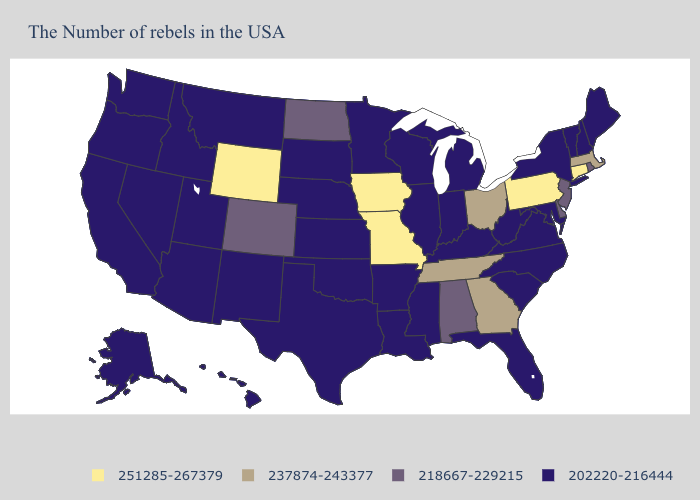What is the highest value in the Northeast ?
Keep it brief. 251285-267379. What is the lowest value in the South?
Keep it brief. 202220-216444. Name the states that have a value in the range 218667-229215?
Keep it brief. Rhode Island, New Jersey, Delaware, Alabama, North Dakota, Colorado. Does Massachusetts have a higher value than Delaware?
Give a very brief answer. Yes. What is the lowest value in the USA?
Be succinct. 202220-216444. Which states hav the highest value in the West?
Be succinct. Wyoming. Name the states that have a value in the range 251285-267379?
Quick response, please. Connecticut, Pennsylvania, Missouri, Iowa, Wyoming. What is the value of Washington?
Be succinct. 202220-216444. Name the states that have a value in the range 237874-243377?
Quick response, please. Massachusetts, Ohio, Georgia, Tennessee. Does Tennessee have a higher value than Massachusetts?
Give a very brief answer. No. Among the states that border Arkansas , does Mississippi have the lowest value?
Keep it brief. Yes. What is the value of Wisconsin?
Be succinct. 202220-216444. What is the lowest value in states that border New York?
Short answer required. 202220-216444. Does South Dakota have a lower value than Virginia?
Give a very brief answer. No. Does Mississippi have the lowest value in the USA?
Concise answer only. Yes. 